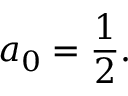<formula> <loc_0><loc_0><loc_500><loc_500>a _ { 0 } = { \frac { 1 } { 2 } } .</formula> 